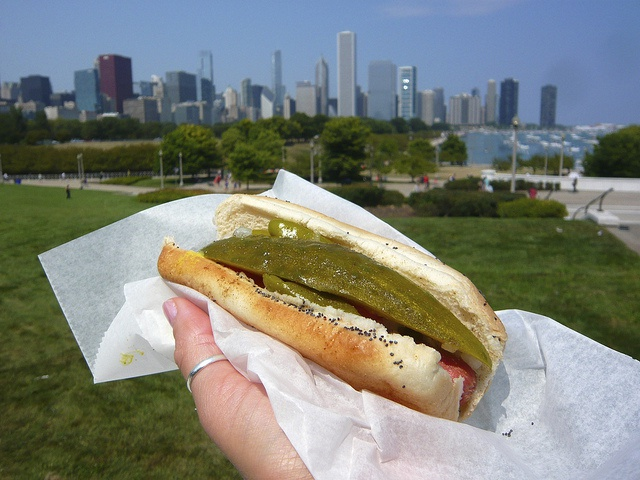Describe the objects in this image and their specific colors. I can see hot dog in gray, olive, and tan tones, people in gray, lightpink, and tan tones, boat in gray and darkgray tones, people in gray, brown, and maroon tones, and people in gray, black, and darkgreen tones in this image. 